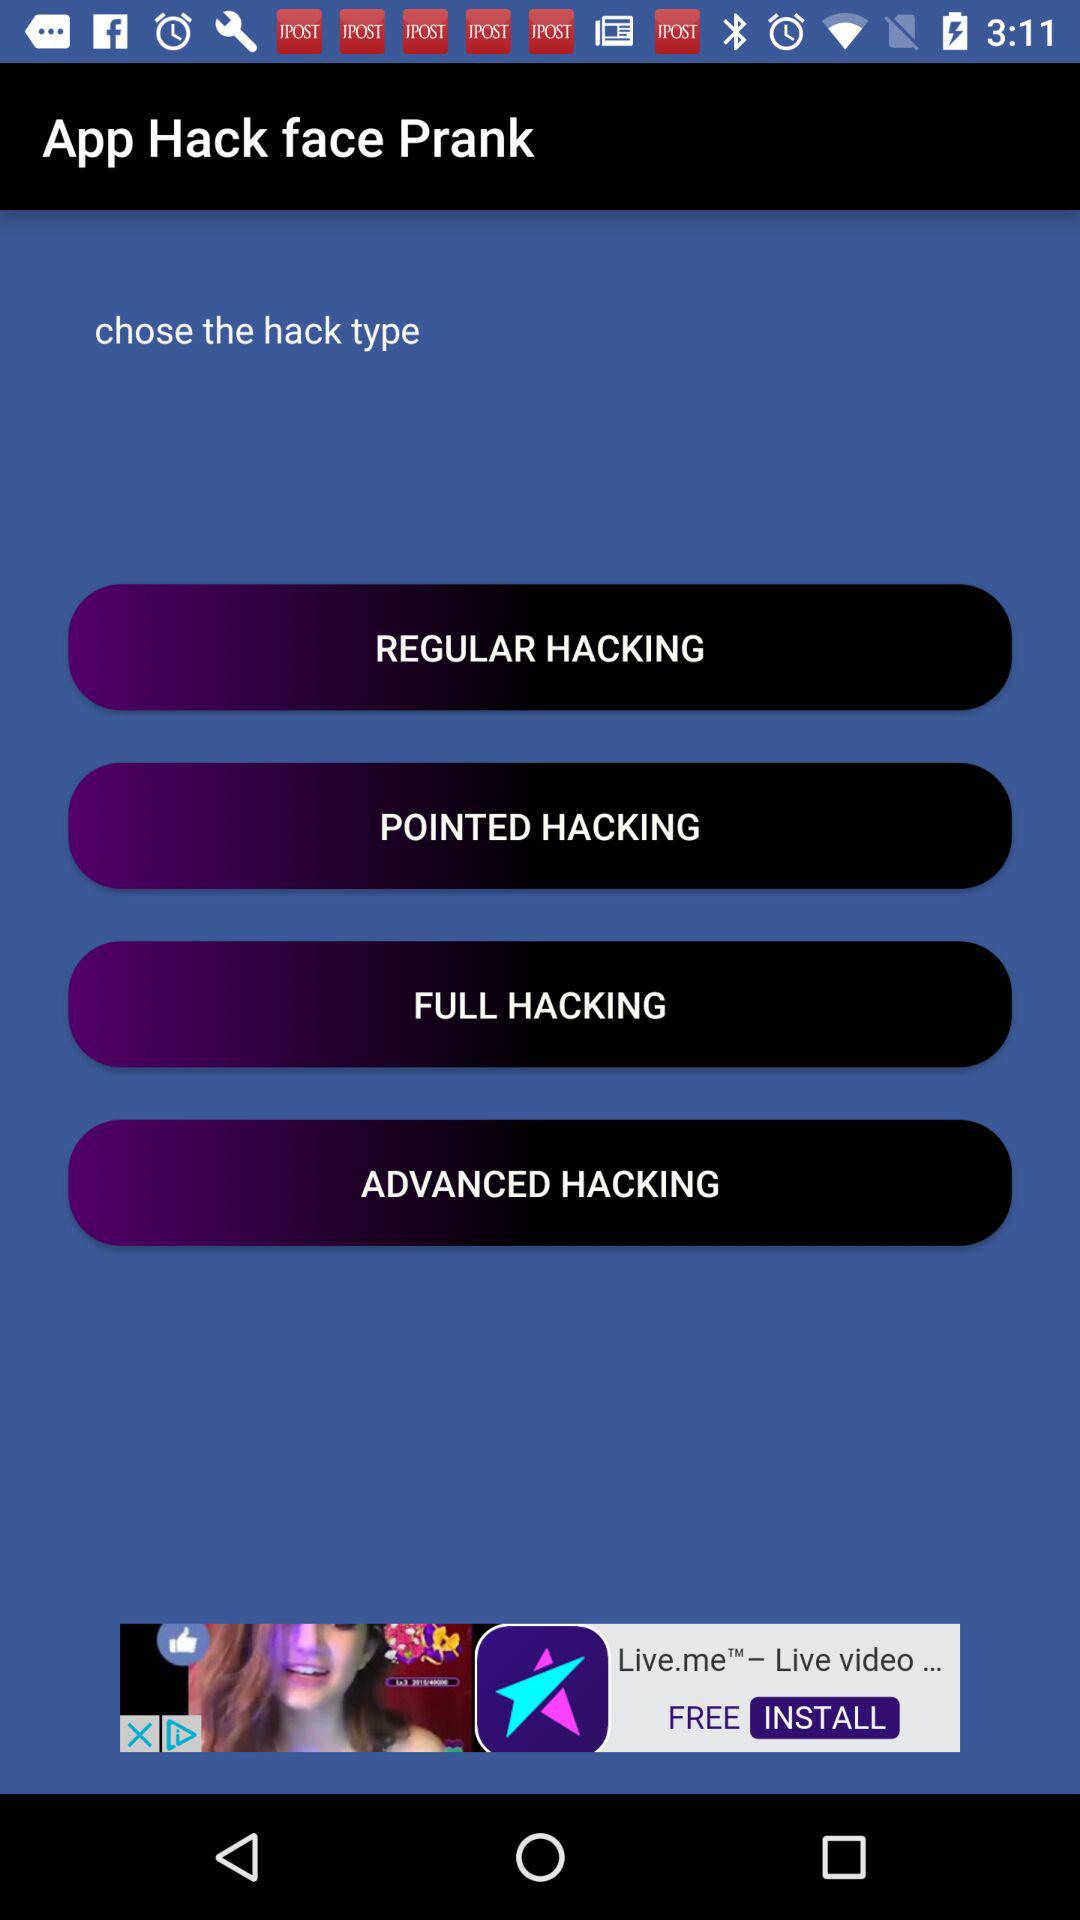How much can be done in "FULL HACKING"?
When the provided information is insufficient, respond with <no answer>. <no answer> 